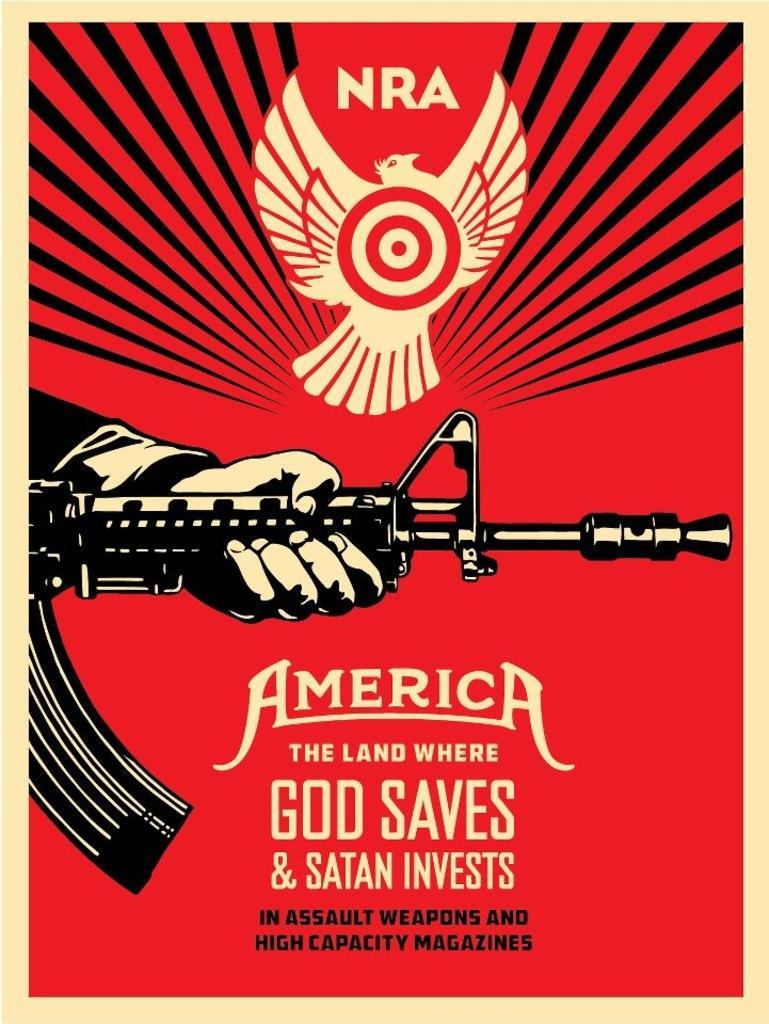In one or two sentences, can you explain what this image depicts? In this image I can see the poster. In the poster I can see the person holding the weapon. And there is something is written on it. I can also see the poster is in red, black and cream color. 